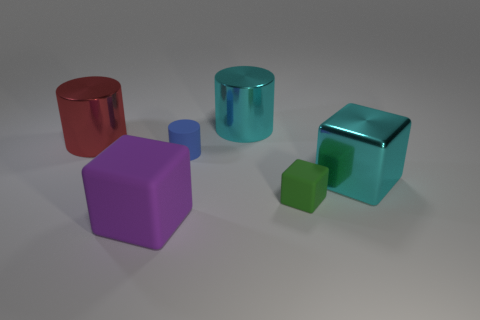What number of red things are big shiny objects or tiny blocks?
Make the answer very short. 1. What number of metal cylinders have the same size as the red thing?
Your answer should be compact. 1. The thing that is the same color as the big shiny block is what shape?
Offer a very short reply. Cylinder. How many objects are either tiny blue rubber objects or metallic objects that are right of the tiny blue cylinder?
Your answer should be compact. 3. Do the cyan object that is behind the cyan shiny block and the metal cylinder on the left side of the big rubber block have the same size?
Your response must be concise. Yes. How many cyan metal objects are the same shape as the blue object?
Your answer should be very brief. 1. There is a red object that is made of the same material as the large cyan block; what shape is it?
Provide a short and direct response. Cylinder. What is the cyan thing that is on the left side of the object right of the matte block that is behind the purple rubber object made of?
Give a very brief answer. Metal. There is a green thing; is it the same size as the cube that is on the right side of the tiny green block?
Offer a very short reply. No. What is the material of the small green object that is the same shape as the large rubber object?
Give a very brief answer. Rubber. 